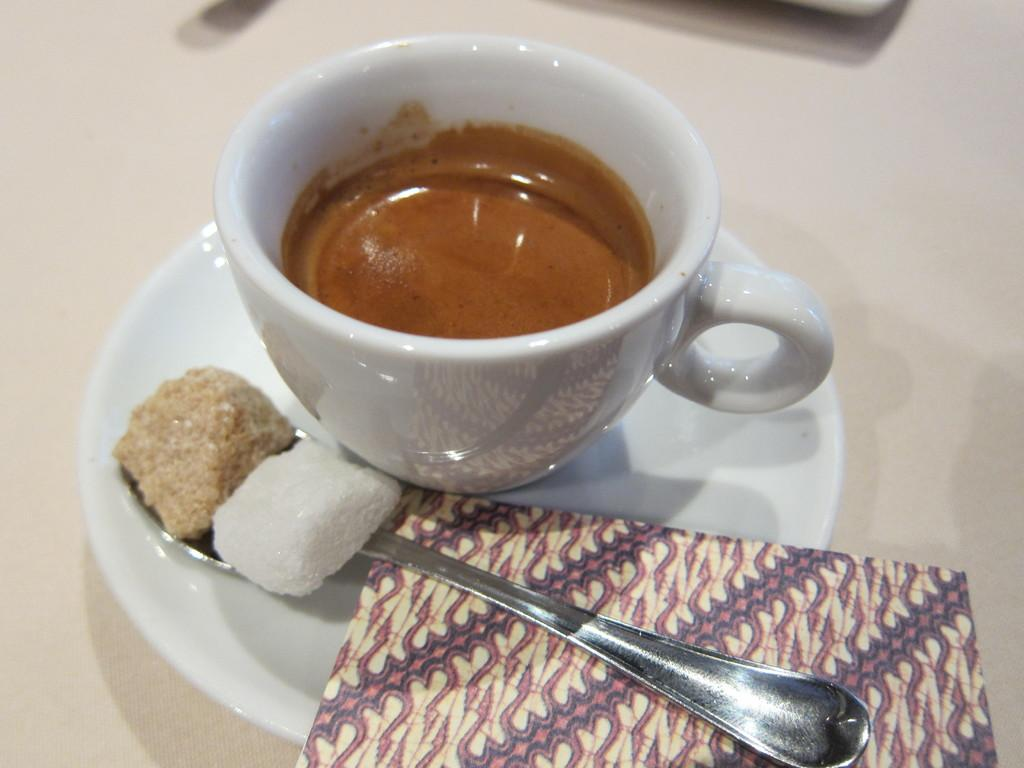What is in the cup that is visible in the image? There is coffee in a cup in the image. How is the cup placed on the saucer? The cup is placed on a saucer in the image. What is the spoon used for in the image? The spoon is used for sugar cubicle in the image. What might be used for cleaning or wiping in the image? A napkin is present on the saucer for cleaning or wiping. How many bananas are on the saucer in the image? There are no bananas present on the saucer in the image. What type of bread is being served with the coffee in the image? There is no bread present in the image. 